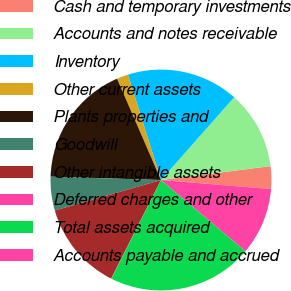<chart> <loc_0><loc_0><loc_500><loc_500><pie_chart><fcel>Cash and temporary investments<fcel>Accounts and notes receivable<fcel>Inventory<fcel>Other current assets<fcel>Plants properties and<fcel>Goodwill<fcel>Other intangible assets<fcel>Deferred charges and other<fcel>Total assets acquired<fcel>Accounts payable and accrued<nl><fcel>3.31%<fcel>11.47%<fcel>16.37%<fcel>1.67%<fcel>18.0%<fcel>4.94%<fcel>13.1%<fcel>0.04%<fcel>21.27%<fcel>9.84%<nl></chart> 